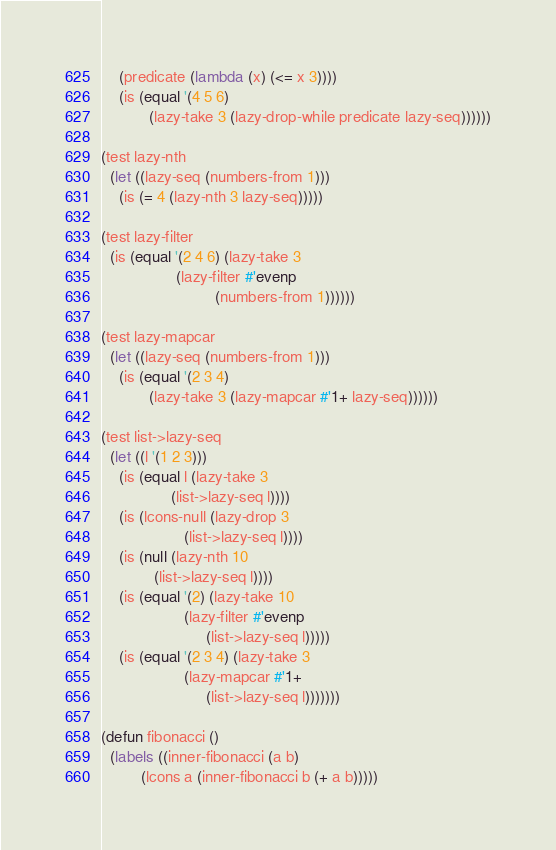<code> <loc_0><loc_0><loc_500><loc_500><_Lisp_>	(predicate (lambda (x) (<= x 3))))
    (is (equal '(4 5 6)
	       (lazy-take 3 (lazy-drop-while predicate lazy-seq))))))

(test lazy-nth
  (let ((lazy-seq (numbers-from 1)))
    (is (= 4 (lazy-nth 3 lazy-seq)))))

(test lazy-filter
  (is (equal '(2 4 6) (lazy-take 3
				 (lazy-filter #'evenp
					      (numbers-from 1))))))

(test lazy-mapcar
  (let ((lazy-seq (numbers-from 1)))
    (is (equal '(2 3 4)
	       (lazy-take 3 (lazy-mapcar #'1+ lazy-seq))))))

(test list->lazy-seq
  (let ((l '(1 2 3)))
    (is (equal l (lazy-take 3
			    (list->lazy-seq l))))
    (is (lcons-null (lazy-drop 3
			       (list->lazy-seq l))))
    (is (null (lazy-nth 10
			(list->lazy-seq l))))
    (is (equal '(2) (lazy-take 10
			       (lazy-filter #'evenp
					    (list->lazy-seq l)))))
    (is (equal '(2 3 4) (lazy-take 3
				   (lazy-mapcar #'1+
						(list->lazy-seq l)))))))

(defun fibonacci ()
  (labels ((inner-fibonacci (a b)
	     (lcons a (inner-fibonacci b (+ a b)))))</code> 